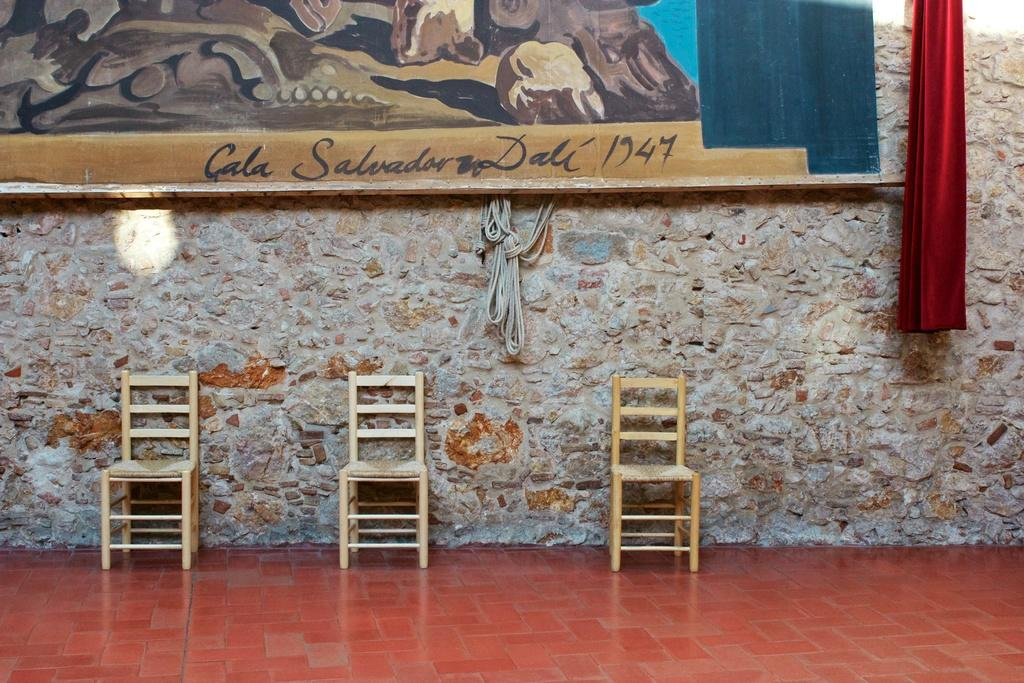Provide a one-sentence caption for the provided image. Three wood chairs sit under a large Salvador Dali painting. 